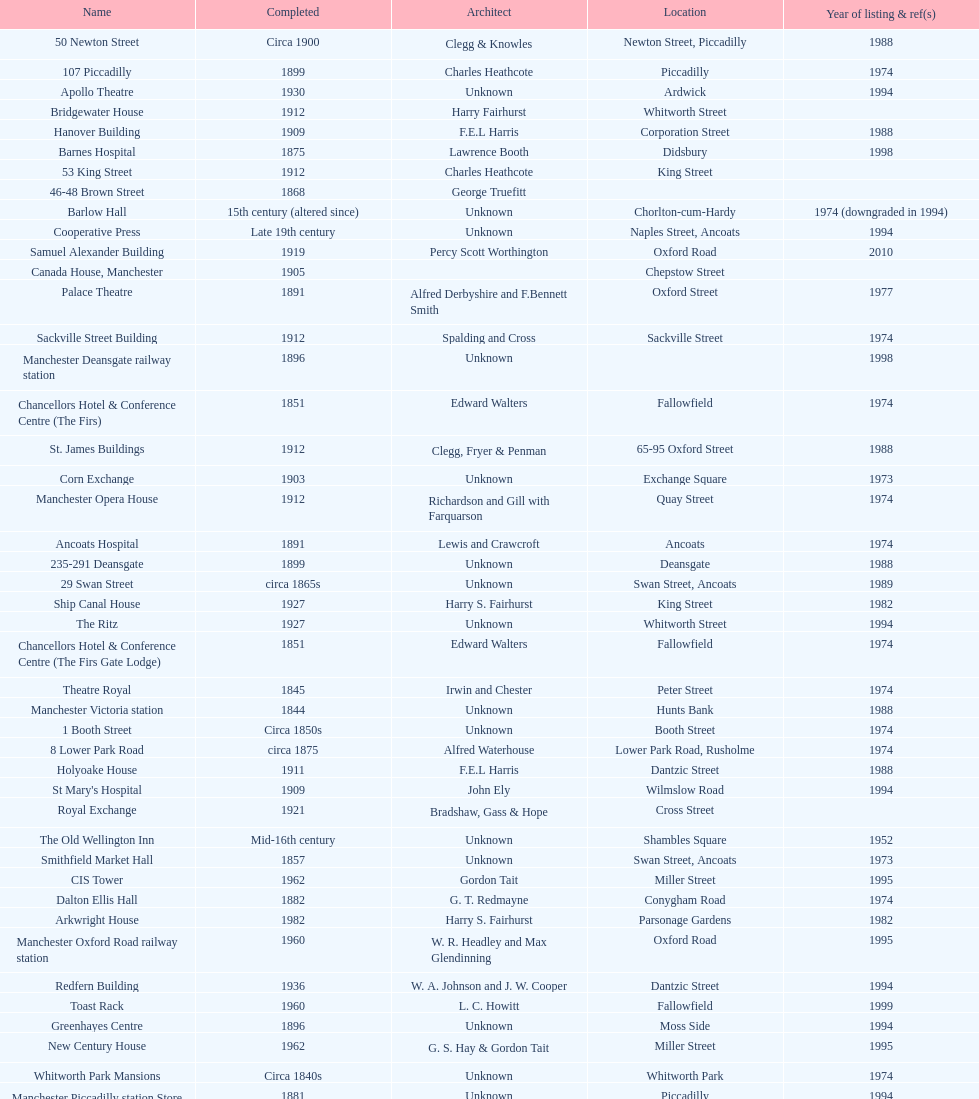How many buildings do not have an image listed? 11. 